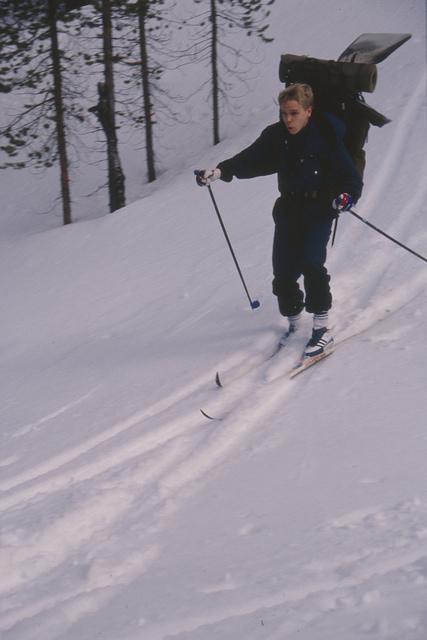How many trees are in the background?
Give a very brief answer. 4. How many trees are in the photo?
Give a very brief answer. 4. How many black cars are in the picture?
Give a very brief answer. 0. 